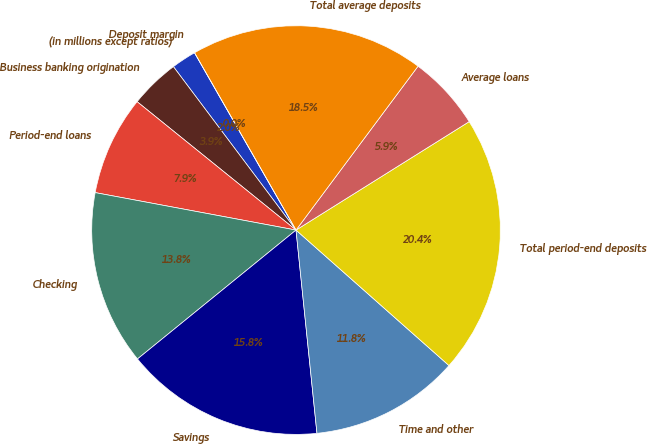<chart> <loc_0><loc_0><loc_500><loc_500><pie_chart><fcel>(in millions except ratios)<fcel>Business banking origination<fcel>Period-end loans<fcel>Checking<fcel>Savings<fcel>Time and other<fcel>Total period-end deposits<fcel>Average loans<fcel>Total average deposits<fcel>Deposit margin<nl><fcel>1.97%<fcel>3.94%<fcel>7.88%<fcel>13.8%<fcel>15.77%<fcel>11.83%<fcel>20.44%<fcel>5.91%<fcel>18.46%<fcel>0.0%<nl></chart> 